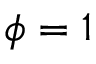<formula> <loc_0><loc_0><loc_500><loc_500>\phi = 1</formula> 